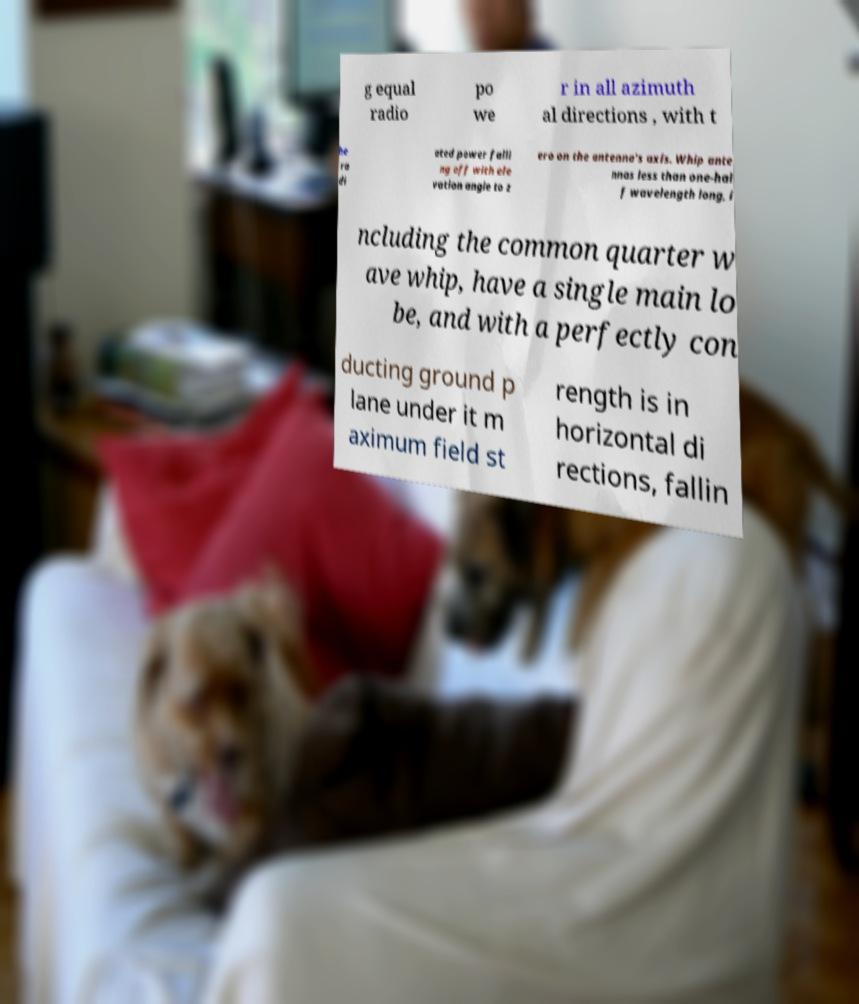There's text embedded in this image that I need extracted. Can you transcribe it verbatim? g equal radio po we r in all azimuth al directions , with t he ra di ated power falli ng off with ele vation angle to z ero on the antenna's axis. Whip ante nnas less than one-hal f wavelength long, i ncluding the common quarter w ave whip, have a single main lo be, and with a perfectly con ducting ground p lane under it m aximum field st rength is in horizontal di rections, fallin 